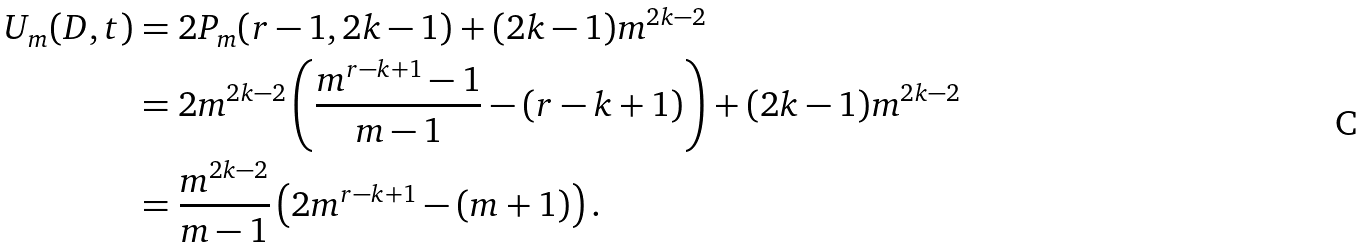<formula> <loc_0><loc_0><loc_500><loc_500>U _ { m } ( D , t ) & = 2 P _ { m } ( r - 1 , 2 k - 1 ) + ( 2 k - 1 ) m ^ { 2 k - 2 } \\ & = 2 m ^ { 2 k - 2 } \left ( \frac { m ^ { r - k + 1 } - 1 } { m - 1 } - ( r - k + 1 ) \right ) + ( 2 k - 1 ) m ^ { 2 k - 2 } \\ & = \frac { m ^ { 2 k - 2 } } { m - 1 } \left ( 2 m ^ { r - k + 1 } - ( m + 1 ) \right ) .</formula> 